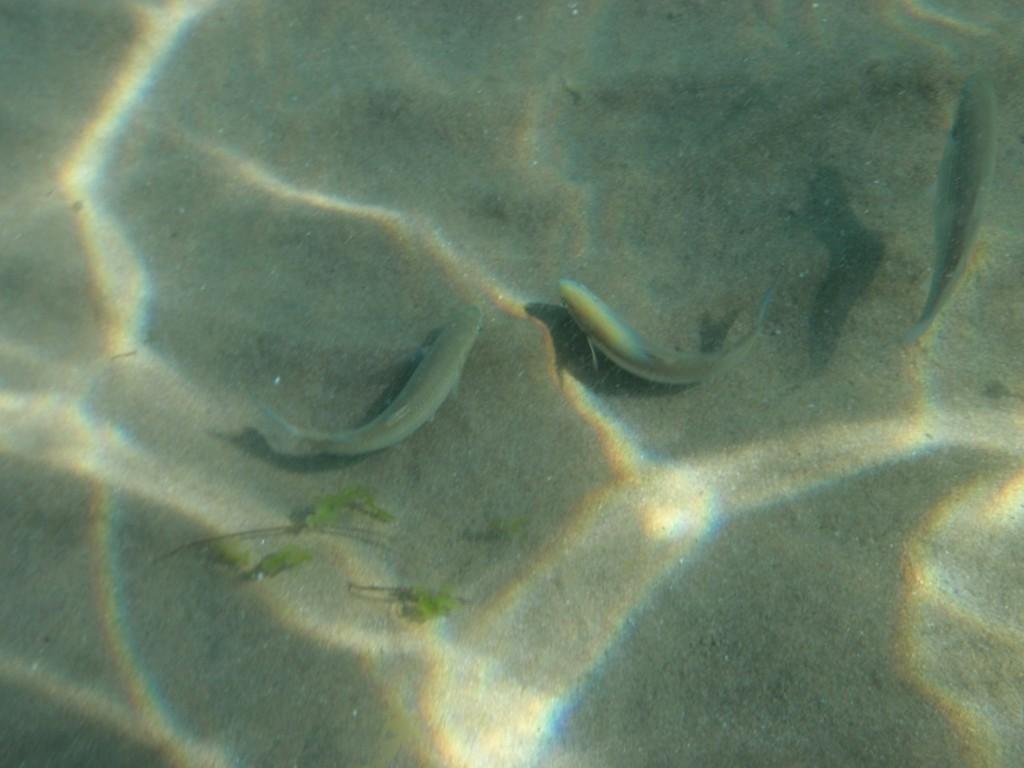Describe this image in one or two sentences. In this image I can see the underwater picture in which I can see few green colored leaves and few fish. 